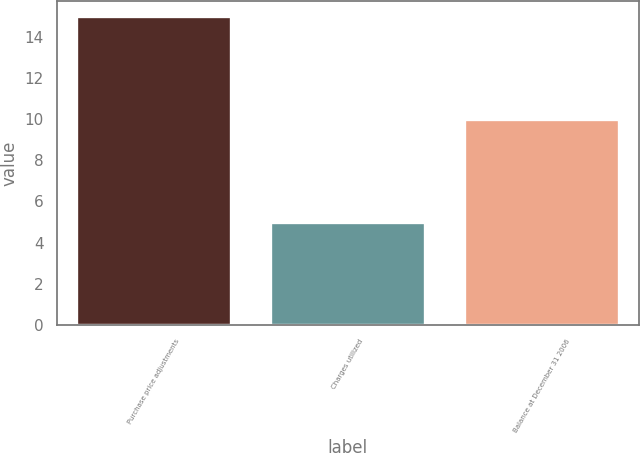Convert chart. <chart><loc_0><loc_0><loc_500><loc_500><bar_chart><fcel>Purchase price adjustments<fcel>Charges utilized<fcel>Balance at December 31 2006<nl><fcel>15<fcel>5<fcel>10<nl></chart> 